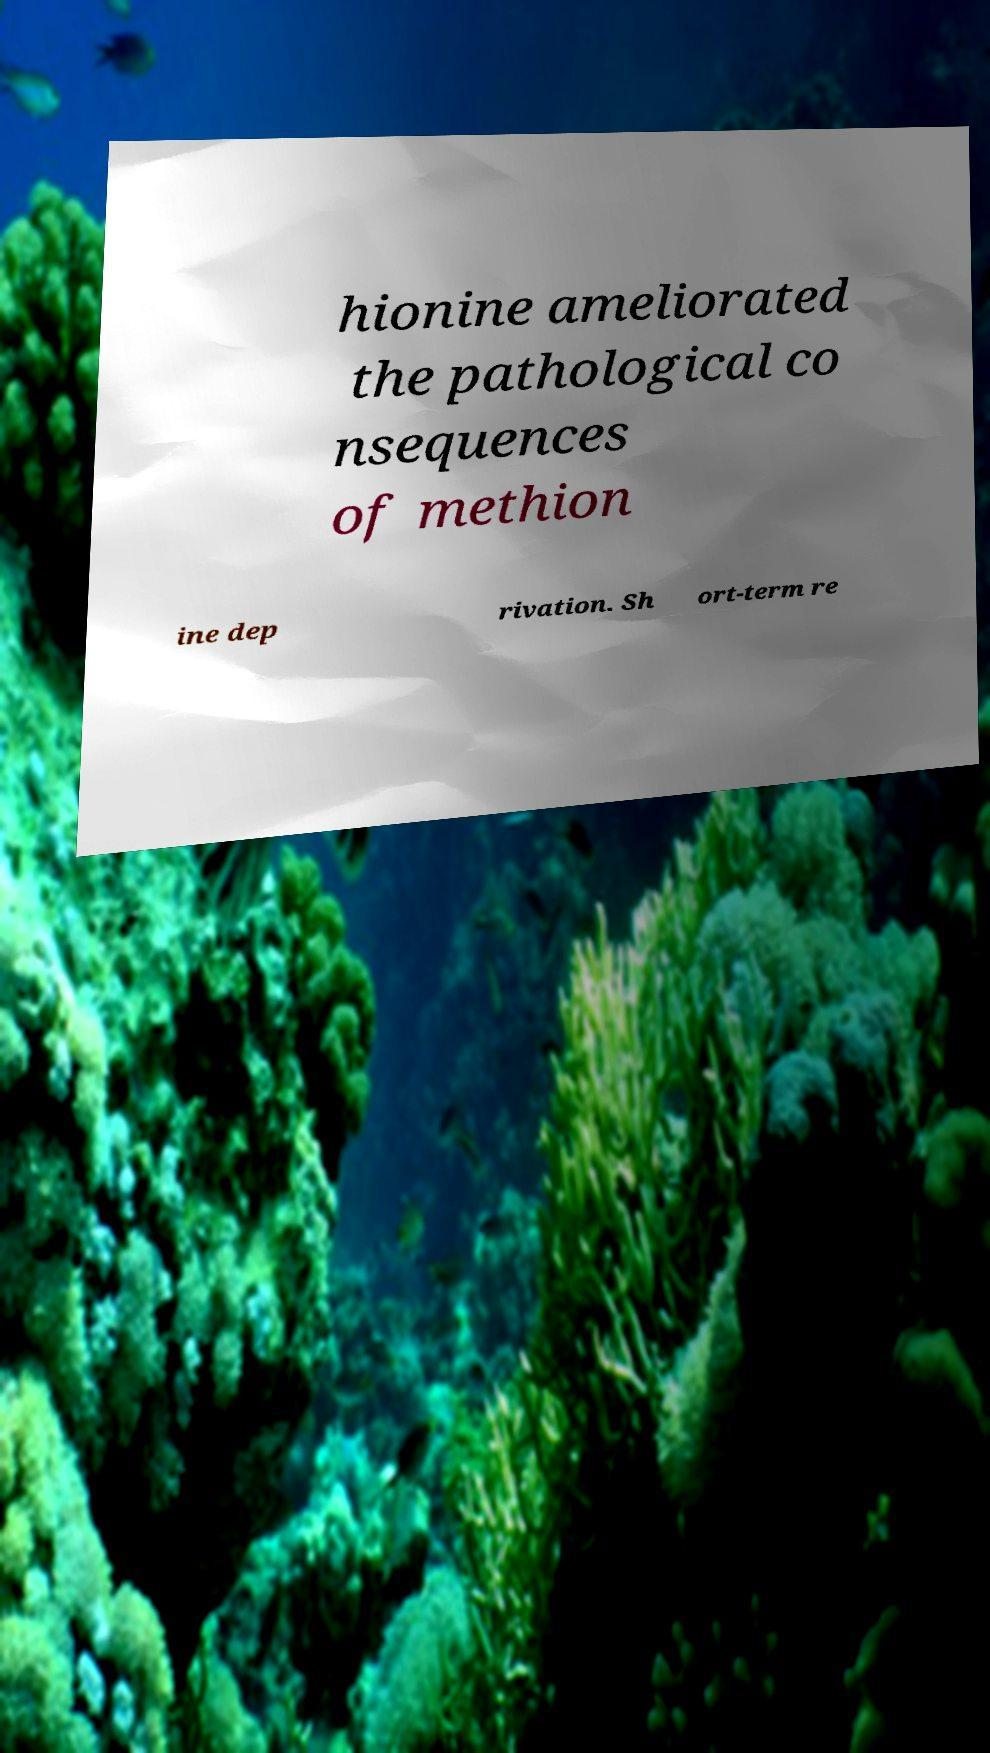Can you accurately transcribe the text from the provided image for me? hionine ameliorated the pathological co nsequences of methion ine dep rivation. Sh ort-term re 